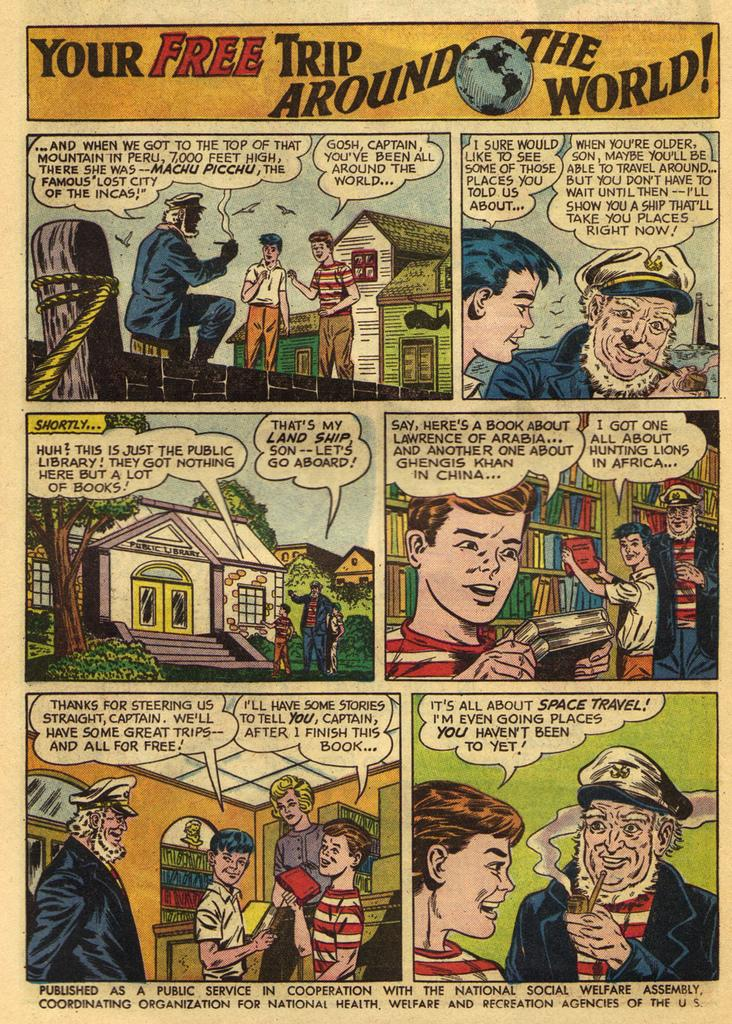<image>
Present a compact description of the photo's key features. A comic strip titled Your Free Trip Around the World. 